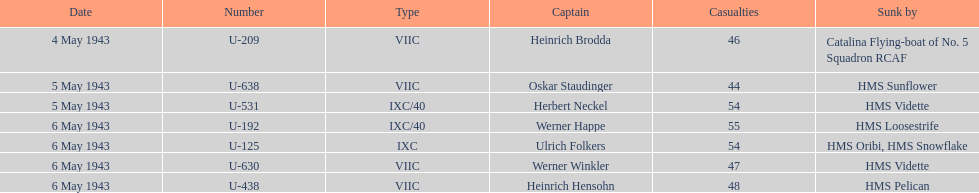How many additional casualties took place on may 6 in comparison to may 4? 158. 